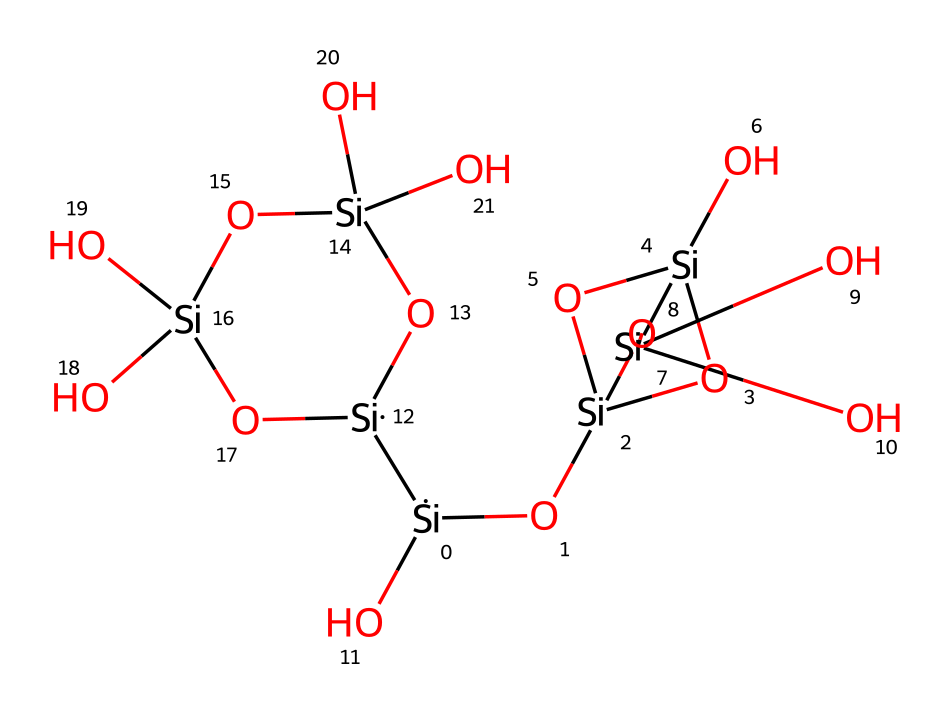What is the total number of silicon atoms in the silsesquioxane structure? By analyzing the SMILES representation, we can count the number of '[Si]' entries, which indicate the presence of silicon atoms. In this case, we find a total of five silicon atoms present in the structure.
Answer: five How many oxygen atoms are there in the compound? The SMILES representation includes several instances of 'O', representing the oxygen atoms. Counting each 'O' gives a total of ten oxygen atoms present in the silsesquioxane structure.
Answer: ten What type of chemical structure is represented by this SMILES? The presence of silicon and oxygen in a cage-like arrangement, along with its unique bonded pattern, suggests that this structure is a silsesquioxane, a specific type of organosilicon compound.
Answer: silsesquioxane What is the coordination number of each silicon atom in the structure? Most silicon atoms typically have a coordination number of four, represented by four bonds to surrounding atoms, which is consistent across the silicon atoms seen in this silsesquioxane structure.
Answer: four What bonding arrangement is primarily present in this silsesquioxane compound? The structure features predominantly tetrahedral bonding due to the silicon's coordination, forming a three-dimensional network indicative of silsesquioxane compounds.
Answer: tetrahedral Is this compound classified as a polymer or a small molecule? Analyzing the structure reveals repeating Si-O units that create a network, which aligns with the characteristics of polymers rather than small molecules. Thus, it is classified as a polymer.
Answer: polymer 